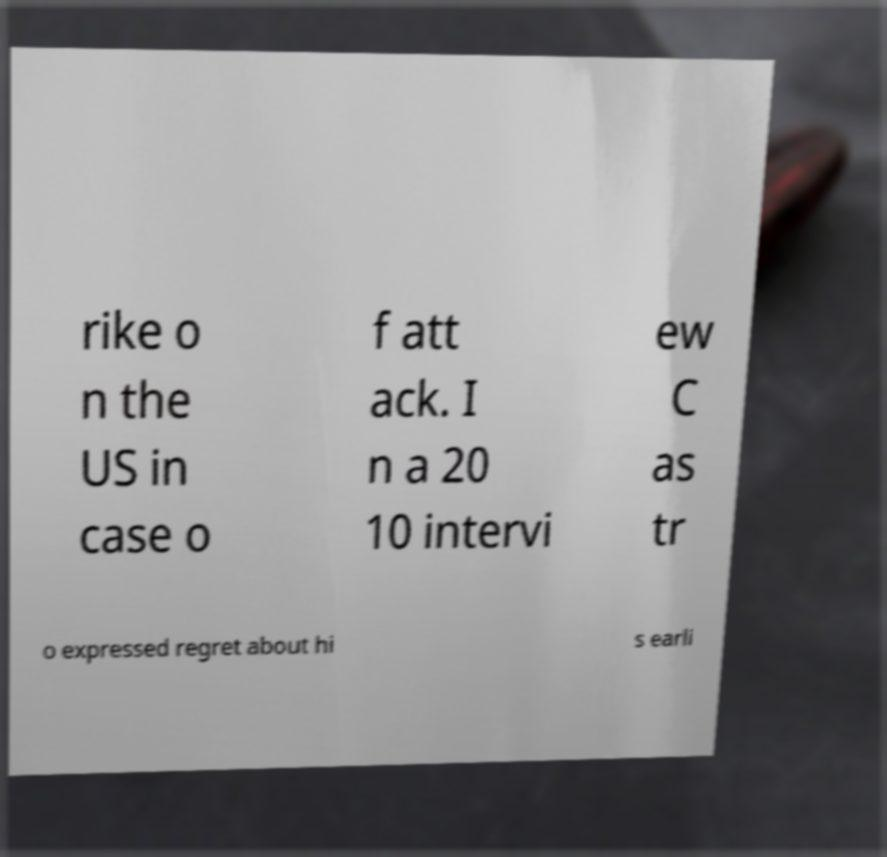For documentation purposes, I need the text within this image transcribed. Could you provide that? rike o n the US in case o f att ack. I n a 20 10 intervi ew C as tr o expressed regret about hi s earli 